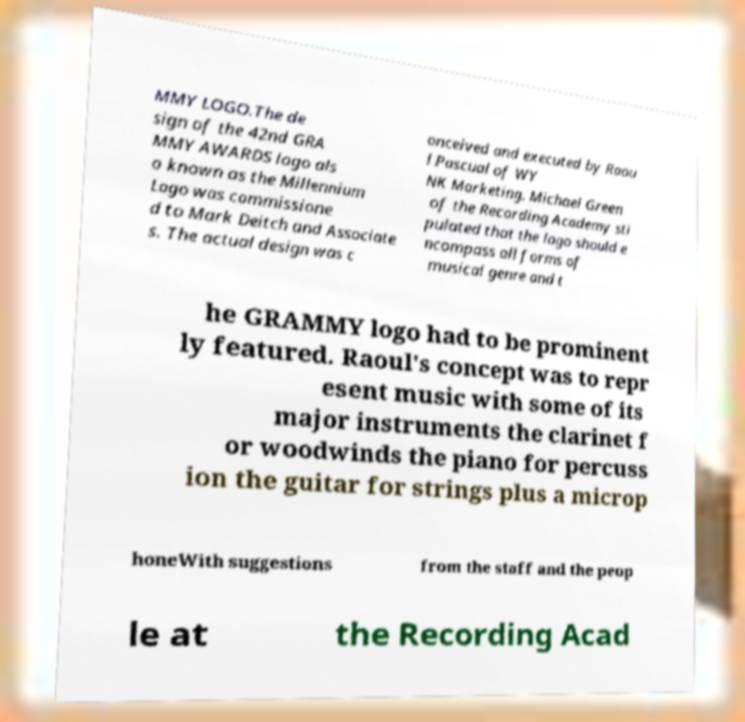Please identify and transcribe the text found in this image. MMY LOGO.The de sign of the 42nd GRA MMY AWARDS logo als o known as the Millennium Logo was commissione d to Mark Deitch and Associate s. The actual design was c onceived and executed by Raou l Pascual of WY NK Marketing. Michael Green of the Recording Academy sti pulated that the logo should e ncompass all forms of musical genre and t he GRAMMY logo had to be prominent ly featured. Raoul's concept was to repr esent music with some of its major instruments the clarinet f or woodwinds the piano for percuss ion the guitar for strings plus a microp honeWith suggestions from the staff and the peop le at the Recording Acad 